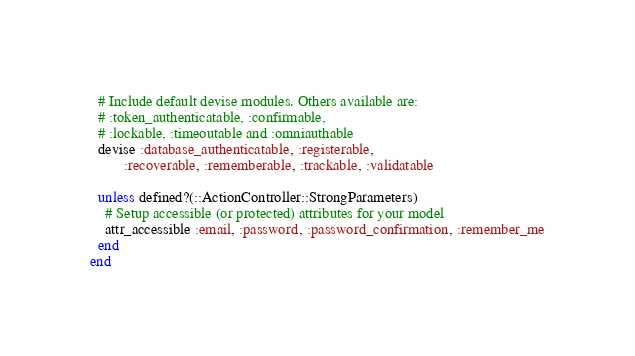Convert code to text. <code><loc_0><loc_0><loc_500><loc_500><_Ruby_>  # Include default devise modules. Others available are:
  # :token_authenticatable, :confirmable,
  # :lockable, :timeoutable and :omniauthable
  devise :database_authenticatable, :registerable,
         :recoverable, :rememberable, :trackable, :validatable

  unless defined?(::ActionController::StrongParameters)
    # Setup accessible (or protected) attributes for your model
    attr_accessible :email, :password, :password_confirmation, :remember_me
  end
end
</code> 